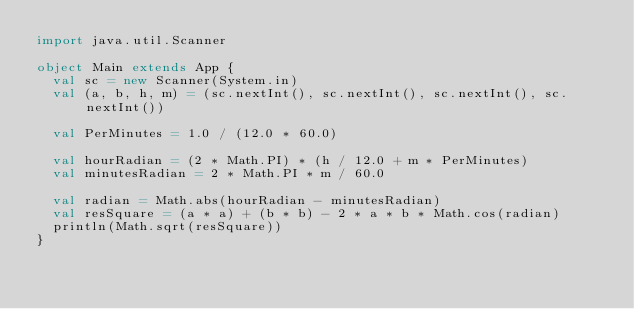<code> <loc_0><loc_0><loc_500><loc_500><_Scala_>import java.util.Scanner

object Main extends App {
  val sc = new Scanner(System.in)
  val (a, b, h, m) = (sc.nextInt(), sc.nextInt(), sc.nextInt(), sc.nextInt())

  val PerMinutes = 1.0 / (12.0 * 60.0)

  val hourRadian = (2 * Math.PI) * (h / 12.0 + m * PerMinutes)
  val minutesRadian = 2 * Math.PI * m / 60.0

  val radian = Math.abs(hourRadian - minutesRadian)
  val resSquare = (a * a) + (b * b) - 2 * a * b * Math.cos(radian)
  println(Math.sqrt(resSquare))
}
</code> 